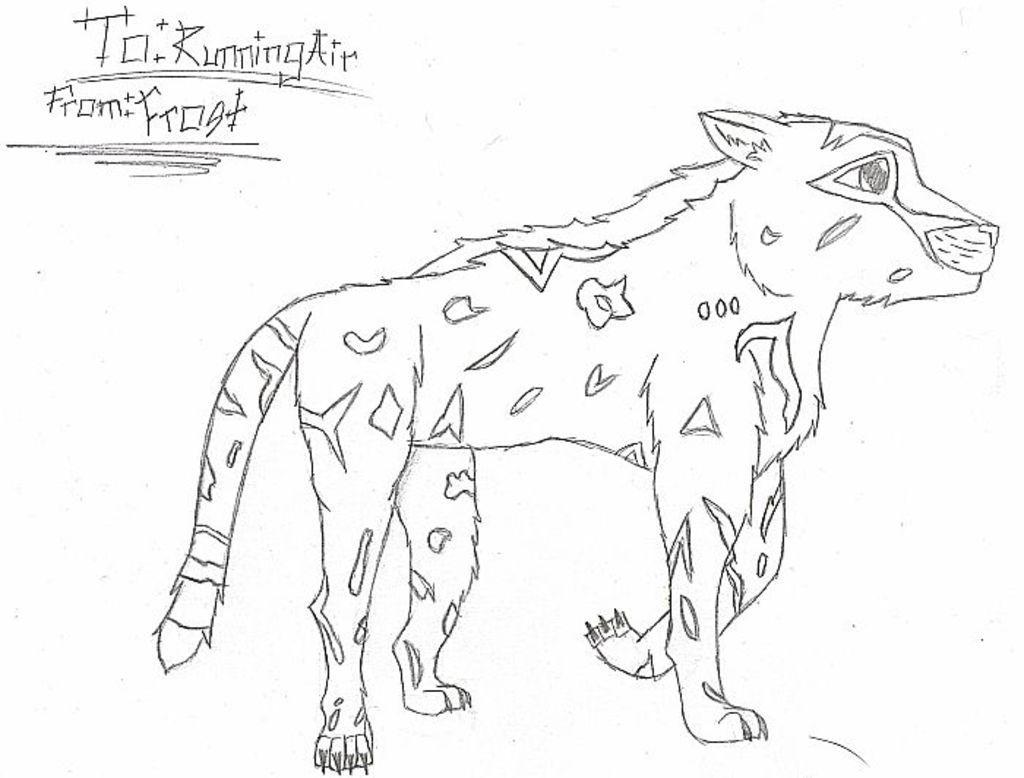Please provide a concise description of this image. In this image I can see a sketch of a wild animal and at the top of the image I can see some text. 